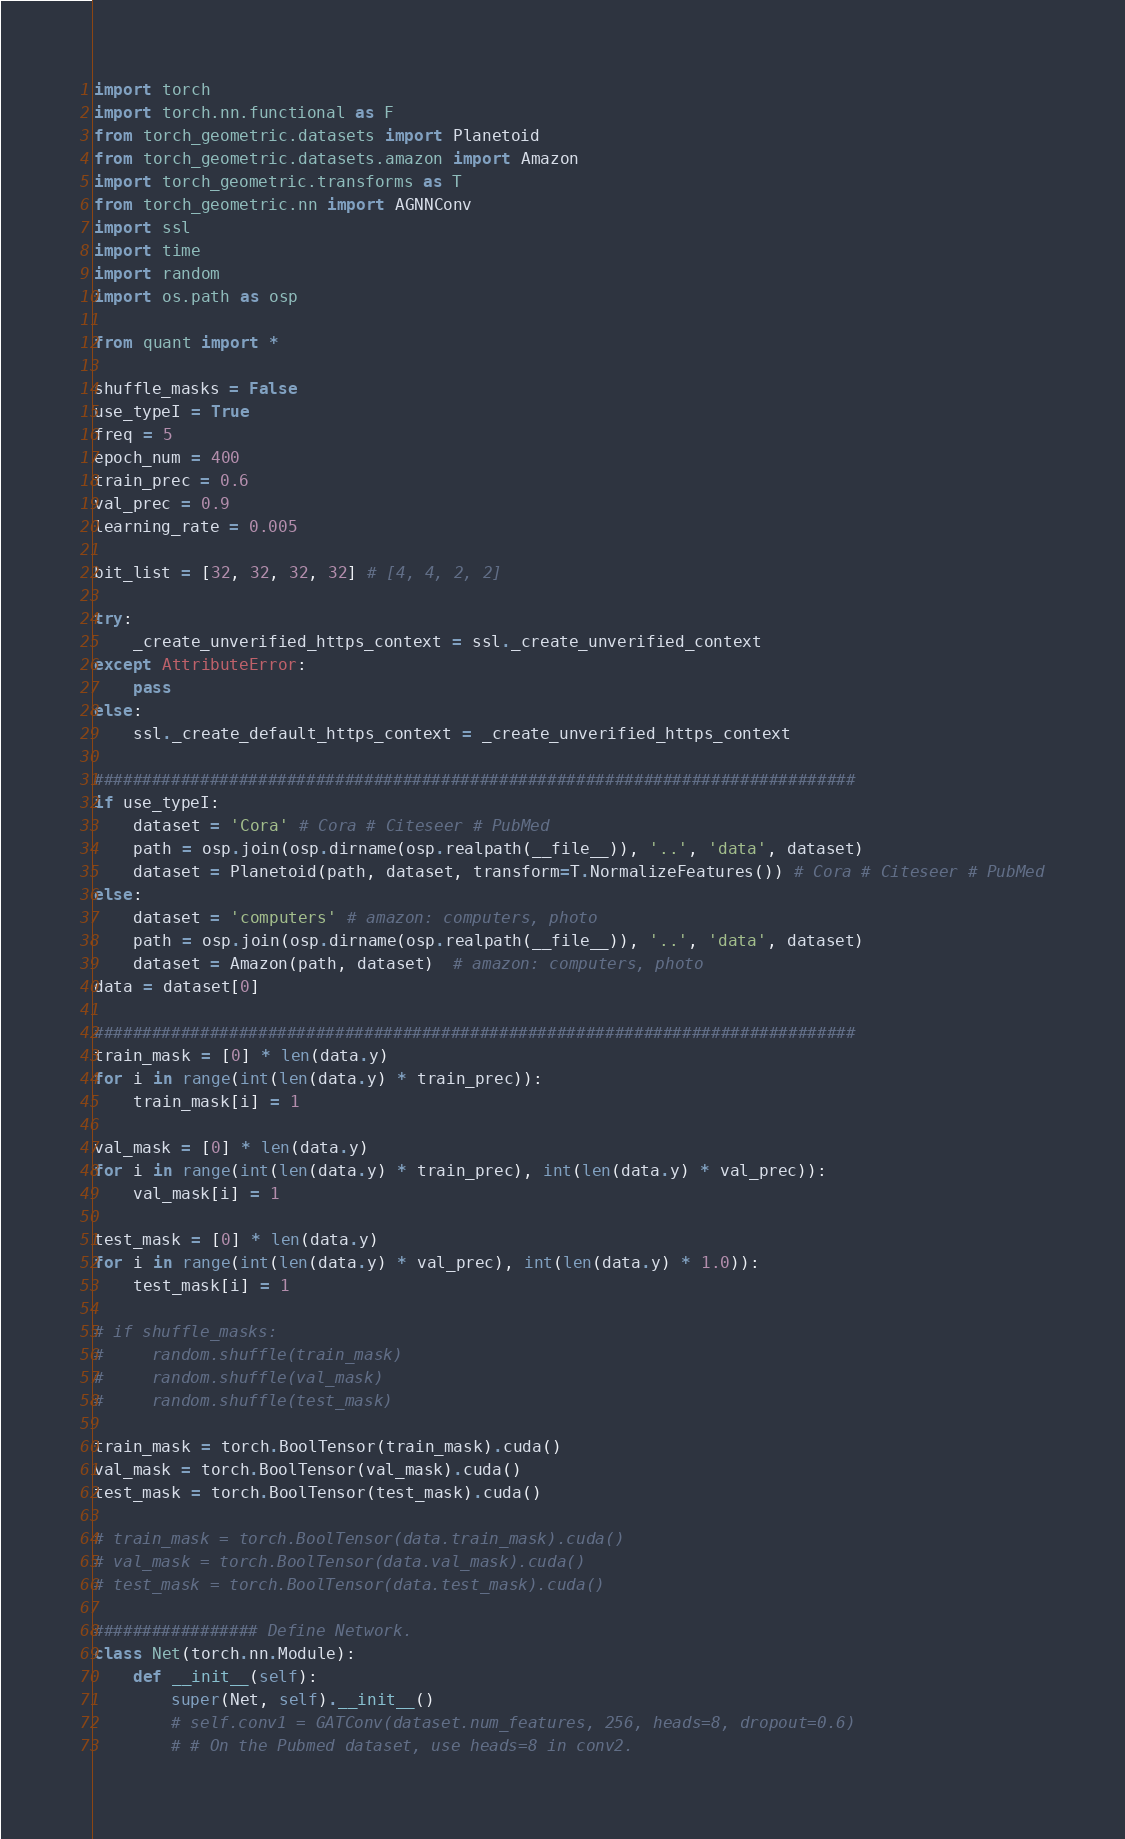Convert code to text. <code><loc_0><loc_0><loc_500><loc_500><_Python_>
import torch
import torch.nn.functional as F
from torch_geometric.datasets import Planetoid
from torch_geometric.datasets.amazon import Amazon
import torch_geometric.transforms as T
from torch_geometric.nn import AGNNConv
import ssl
import time
import random
import os.path as osp

from quant import *

shuffle_masks = False
use_typeI = True
freq = 5
epoch_num = 400
train_prec = 0.6
val_prec = 0.9
learning_rate = 0.005

bit_list = [32, 32, 32, 32] # [4, 4, 2, 2]

try:
    _create_unverified_https_context = ssl._create_unverified_context
except AttributeError:
    pass
else:
    ssl._create_default_https_context = _create_unverified_https_context

###############################################################################
if use_typeI:
    dataset = 'Cora' # Cora # Citeseer # PubMed
    path = osp.join(osp.dirname(osp.realpath(__file__)), '..', 'data', dataset) 
    dataset = Planetoid(path, dataset, transform=T.NormalizeFeatures()) # Cora # Citeseer # PubMed
else:
    dataset = 'computers' # amazon: computers, photo
    path = osp.join(osp.dirname(osp.realpath(__file__)), '..', 'data', dataset) 
    dataset = Amazon(path, dataset)  # amazon: computers, photo
data = dataset[0]

###############################################################################
train_mask = [0] * len(data.y)
for i in range(int(len(data.y) * train_prec)): 
    train_mask[i] = 1

val_mask = [0] * len(data.y)
for i in range(int(len(data.y) * train_prec), int(len(data.y) * val_prec)):
    val_mask[i] = 1

test_mask = [0] * len(data.y)
for i in range(int(len(data.y) * val_prec), int(len(data.y) * 1.0)):
    test_mask[i] = 1

# if shuffle_masks:
#     random.shuffle(train_mask)
#     random.shuffle(val_mask)
#     random.shuffle(test_mask)

train_mask = torch.BoolTensor(train_mask).cuda()
val_mask = torch.BoolTensor(val_mask).cuda()
test_mask = torch.BoolTensor(test_mask).cuda()

# train_mask = torch.BoolTensor(data.train_mask).cuda()
# val_mask = torch.BoolTensor(data.val_mask).cuda()
# test_mask = torch.BoolTensor(data.test_mask).cuda()

################# Define Network.
class Net(torch.nn.Module):
    def __init__(self):
        super(Net, self).__init__()
        # self.conv1 = GATConv(dataset.num_features, 256, heads=8, dropout=0.6)
        # # On the Pubmed dataset, use heads=8 in conv2.</code> 